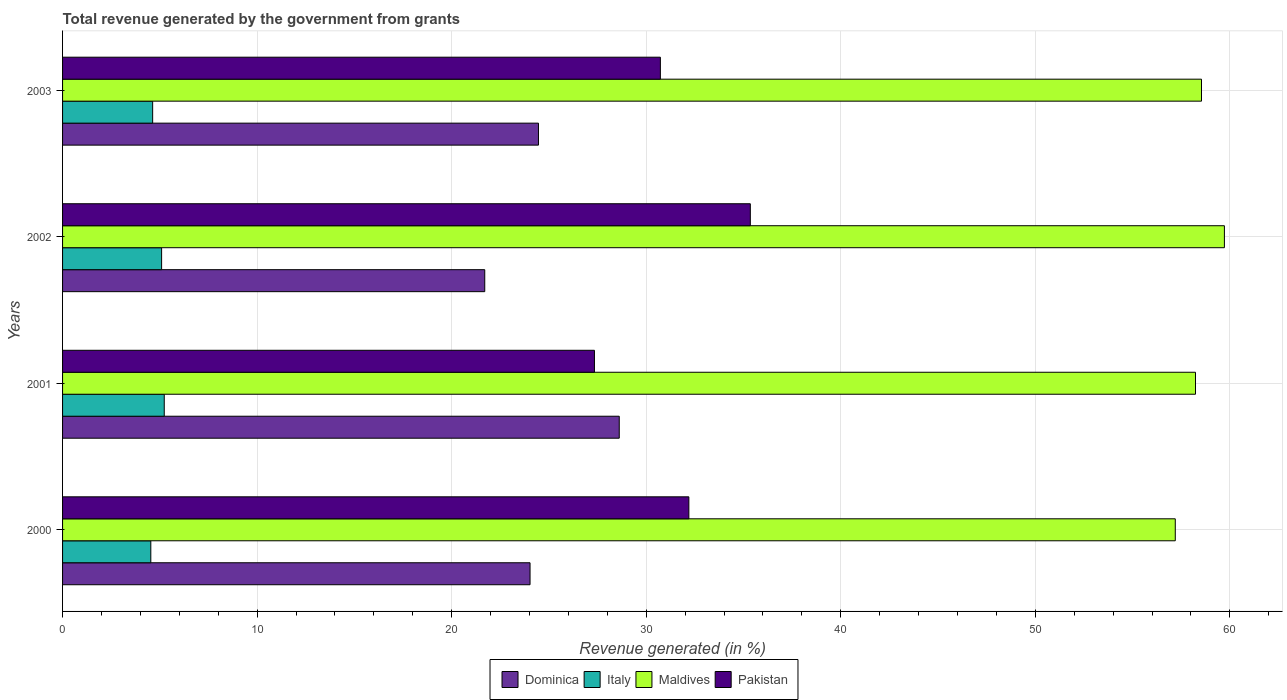How many different coloured bars are there?
Keep it short and to the point. 4. How many bars are there on the 4th tick from the top?
Your response must be concise. 4. In how many cases, is the number of bars for a given year not equal to the number of legend labels?
Provide a short and direct response. 0. What is the total revenue generated in Italy in 2001?
Offer a very short reply. 5.23. Across all years, what is the maximum total revenue generated in Maldives?
Provide a short and direct response. 59.72. Across all years, what is the minimum total revenue generated in Italy?
Give a very brief answer. 4.54. In which year was the total revenue generated in Italy maximum?
Offer a terse response. 2001. What is the total total revenue generated in Italy in the graph?
Provide a succinct answer. 19.48. What is the difference between the total revenue generated in Dominica in 2000 and that in 2001?
Offer a very short reply. -4.59. What is the difference between the total revenue generated in Italy in 2000 and the total revenue generated in Dominica in 2001?
Your response must be concise. -24.08. What is the average total revenue generated in Italy per year?
Provide a succinct answer. 4.87. In the year 2002, what is the difference between the total revenue generated in Italy and total revenue generated in Maldives?
Ensure brevity in your answer.  -54.63. What is the ratio of the total revenue generated in Pakistan in 2001 to that in 2003?
Provide a succinct answer. 0.89. Is the difference between the total revenue generated in Italy in 2000 and 2002 greater than the difference between the total revenue generated in Maldives in 2000 and 2002?
Provide a short and direct response. Yes. What is the difference between the highest and the second highest total revenue generated in Pakistan?
Give a very brief answer. 3.16. What is the difference between the highest and the lowest total revenue generated in Pakistan?
Ensure brevity in your answer.  8.01. In how many years, is the total revenue generated in Pakistan greater than the average total revenue generated in Pakistan taken over all years?
Make the answer very short. 2. What does the 3rd bar from the bottom in 2002 represents?
Provide a succinct answer. Maldives. How many years are there in the graph?
Ensure brevity in your answer.  4. What is the difference between two consecutive major ticks on the X-axis?
Your answer should be compact. 10. Are the values on the major ticks of X-axis written in scientific E-notation?
Your answer should be compact. No. Does the graph contain any zero values?
Your answer should be very brief. No. How many legend labels are there?
Give a very brief answer. 4. What is the title of the graph?
Provide a short and direct response. Total revenue generated by the government from grants. Does "Netherlands" appear as one of the legend labels in the graph?
Your answer should be very brief. No. What is the label or title of the X-axis?
Your answer should be compact. Revenue generated (in %). What is the Revenue generated (in %) of Dominica in 2000?
Your answer should be compact. 24.03. What is the Revenue generated (in %) of Italy in 2000?
Your response must be concise. 4.54. What is the Revenue generated (in %) in Maldives in 2000?
Provide a short and direct response. 57.2. What is the Revenue generated (in %) in Pakistan in 2000?
Your answer should be very brief. 32.19. What is the Revenue generated (in %) in Dominica in 2001?
Make the answer very short. 28.62. What is the Revenue generated (in %) in Italy in 2001?
Offer a very short reply. 5.23. What is the Revenue generated (in %) in Maldives in 2001?
Make the answer very short. 58.24. What is the Revenue generated (in %) of Pakistan in 2001?
Offer a very short reply. 27.34. What is the Revenue generated (in %) in Dominica in 2002?
Keep it short and to the point. 21.7. What is the Revenue generated (in %) in Italy in 2002?
Keep it short and to the point. 5.09. What is the Revenue generated (in %) of Maldives in 2002?
Provide a short and direct response. 59.72. What is the Revenue generated (in %) of Pakistan in 2002?
Your answer should be very brief. 35.35. What is the Revenue generated (in %) in Dominica in 2003?
Make the answer very short. 24.46. What is the Revenue generated (in %) in Italy in 2003?
Offer a very short reply. 4.63. What is the Revenue generated (in %) of Maldives in 2003?
Provide a succinct answer. 58.54. What is the Revenue generated (in %) in Pakistan in 2003?
Provide a succinct answer. 30.73. Across all years, what is the maximum Revenue generated (in %) in Dominica?
Keep it short and to the point. 28.62. Across all years, what is the maximum Revenue generated (in %) of Italy?
Your answer should be very brief. 5.23. Across all years, what is the maximum Revenue generated (in %) in Maldives?
Your answer should be very brief. 59.72. Across all years, what is the maximum Revenue generated (in %) in Pakistan?
Offer a very short reply. 35.35. Across all years, what is the minimum Revenue generated (in %) of Dominica?
Your answer should be very brief. 21.7. Across all years, what is the minimum Revenue generated (in %) in Italy?
Keep it short and to the point. 4.54. Across all years, what is the minimum Revenue generated (in %) in Maldives?
Provide a succinct answer. 57.2. Across all years, what is the minimum Revenue generated (in %) of Pakistan?
Offer a very short reply. 27.34. What is the total Revenue generated (in %) in Dominica in the graph?
Your answer should be very brief. 98.81. What is the total Revenue generated (in %) in Italy in the graph?
Your answer should be compact. 19.48. What is the total Revenue generated (in %) in Maldives in the graph?
Your answer should be compact. 233.7. What is the total Revenue generated (in %) of Pakistan in the graph?
Provide a short and direct response. 125.62. What is the difference between the Revenue generated (in %) in Dominica in 2000 and that in 2001?
Provide a short and direct response. -4.59. What is the difference between the Revenue generated (in %) in Italy in 2000 and that in 2001?
Your answer should be very brief. -0.69. What is the difference between the Revenue generated (in %) of Maldives in 2000 and that in 2001?
Your response must be concise. -1.04. What is the difference between the Revenue generated (in %) of Pakistan in 2000 and that in 2001?
Provide a short and direct response. 4.85. What is the difference between the Revenue generated (in %) of Dominica in 2000 and that in 2002?
Your answer should be very brief. 2.33. What is the difference between the Revenue generated (in %) of Italy in 2000 and that in 2002?
Ensure brevity in your answer.  -0.55. What is the difference between the Revenue generated (in %) of Maldives in 2000 and that in 2002?
Provide a succinct answer. -2.53. What is the difference between the Revenue generated (in %) of Pakistan in 2000 and that in 2002?
Provide a short and direct response. -3.16. What is the difference between the Revenue generated (in %) of Dominica in 2000 and that in 2003?
Provide a short and direct response. -0.43. What is the difference between the Revenue generated (in %) of Italy in 2000 and that in 2003?
Provide a succinct answer. -0.09. What is the difference between the Revenue generated (in %) in Maldives in 2000 and that in 2003?
Ensure brevity in your answer.  -1.35. What is the difference between the Revenue generated (in %) of Pakistan in 2000 and that in 2003?
Keep it short and to the point. 1.46. What is the difference between the Revenue generated (in %) of Dominica in 2001 and that in 2002?
Give a very brief answer. 6.91. What is the difference between the Revenue generated (in %) in Italy in 2001 and that in 2002?
Your answer should be very brief. 0.14. What is the difference between the Revenue generated (in %) in Maldives in 2001 and that in 2002?
Give a very brief answer. -1.49. What is the difference between the Revenue generated (in %) in Pakistan in 2001 and that in 2002?
Offer a very short reply. -8.01. What is the difference between the Revenue generated (in %) in Dominica in 2001 and that in 2003?
Offer a terse response. 4.15. What is the difference between the Revenue generated (in %) of Italy in 2001 and that in 2003?
Your response must be concise. 0.6. What is the difference between the Revenue generated (in %) of Maldives in 2001 and that in 2003?
Give a very brief answer. -0.31. What is the difference between the Revenue generated (in %) in Pakistan in 2001 and that in 2003?
Make the answer very short. -3.39. What is the difference between the Revenue generated (in %) in Dominica in 2002 and that in 2003?
Offer a very short reply. -2.76. What is the difference between the Revenue generated (in %) in Italy in 2002 and that in 2003?
Give a very brief answer. 0.46. What is the difference between the Revenue generated (in %) of Maldives in 2002 and that in 2003?
Your answer should be very brief. 1.18. What is the difference between the Revenue generated (in %) in Pakistan in 2002 and that in 2003?
Make the answer very short. 4.62. What is the difference between the Revenue generated (in %) in Dominica in 2000 and the Revenue generated (in %) in Italy in 2001?
Your answer should be very brief. 18.8. What is the difference between the Revenue generated (in %) in Dominica in 2000 and the Revenue generated (in %) in Maldives in 2001?
Your answer should be compact. -34.21. What is the difference between the Revenue generated (in %) of Dominica in 2000 and the Revenue generated (in %) of Pakistan in 2001?
Ensure brevity in your answer.  -3.31. What is the difference between the Revenue generated (in %) of Italy in 2000 and the Revenue generated (in %) of Maldives in 2001?
Your answer should be very brief. -53.7. What is the difference between the Revenue generated (in %) in Italy in 2000 and the Revenue generated (in %) in Pakistan in 2001?
Make the answer very short. -22.8. What is the difference between the Revenue generated (in %) in Maldives in 2000 and the Revenue generated (in %) in Pakistan in 2001?
Your response must be concise. 29.86. What is the difference between the Revenue generated (in %) in Dominica in 2000 and the Revenue generated (in %) in Italy in 2002?
Your response must be concise. 18.94. What is the difference between the Revenue generated (in %) in Dominica in 2000 and the Revenue generated (in %) in Maldives in 2002?
Your response must be concise. -35.69. What is the difference between the Revenue generated (in %) of Dominica in 2000 and the Revenue generated (in %) of Pakistan in 2002?
Keep it short and to the point. -11.32. What is the difference between the Revenue generated (in %) in Italy in 2000 and the Revenue generated (in %) in Maldives in 2002?
Offer a terse response. -55.19. What is the difference between the Revenue generated (in %) in Italy in 2000 and the Revenue generated (in %) in Pakistan in 2002?
Your response must be concise. -30.82. What is the difference between the Revenue generated (in %) in Maldives in 2000 and the Revenue generated (in %) in Pakistan in 2002?
Offer a terse response. 21.84. What is the difference between the Revenue generated (in %) of Dominica in 2000 and the Revenue generated (in %) of Italy in 2003?
Your answer should be compact. 19.4. What is the difference between the Revenue generated (in %) of Dominica in 2000 and the Revenue generated (in %) of Maldives in 2003?
Offer a terse response. -34.51. What is the difference between the Revenue generated (in %) of Dominica in 2000 and the Revenue generated (in %) of Pakistan in 2003?
Your answer should be very brief. -6.7. What is the difference between the Revenue generated (in %) of Italy in 2000 and the Revenue generated (in %) of Maldives in 2003?
Keep it short and to the point. -54.01. What is the difference between the Revenue generated (in %) of Italy in 2000 and the Revenue generated (in %) of Pakistan in 2003?
Offer a very short reply. -26.19. What is the difference between the Revenue generated (in %) in Maldives in 2000 and the Revenue generated (in %) in Pakistan in 2003?
Provide a succinct answer. 26.47. What is the difference between the Revenue generated (in %) in Dominica in 2001 and the Revenue generated (in %) in Italy in 2002?
Your response must be concise. 23.52. What is the difference between the Revenue generated (in %) of Dominica in 2001 and the Revenue generated (in %) of Maldives in 2002?
Keep it short and to the point. -31.11. What is the difference between the Revenue generated (in %) in Dominica in 2001 and the Revenue generated (in %) in Pakistan in 2002?
Provide a short and direct response. -6.74. What is the difference between the Revenue generated (in %) in Italy in 2001 and the Revenue generated (in %) in Maldives in 2002?
Your answer should be very brief. -54.5. What is the difference between the Revenue generated (in %) of Italy in 2001 and the Revenue generated (in %) of Pakistan in 2002?
Offer a very short reply. -30.13. What is the difference between the Revenue generated (in %) of Maldives in 2001 and the Revenue generated (in %) of Pakistan in 2002?
Your response must be concise. 22.88. What is the difference between the Revenue generated (in %) of Dominica in 2001 and the Revenue generated (in %) of Italy in 2003?
Your response must be concise. 23.98. What is the difference between the Revenue generated (in %) in Dominica in 2001 and the Revenue generated (in %) in Maldives in 2003?
Provide a succinct answer. -29.93. What is the difference between the Revenue generated (in %) in Dominica in 2001 and the Revenue generated (in %) in Pakistan in 2003?
Ensure brevity in your answer.  -2.11. What is the difference between the Revenue generated (in %) of Italy in 2001 and the Revenue generated (in %) of Maldives in 2003?
Offer a very short reply. -53.32. What is the difference between the Revenue generated (in %) in Italy in 2001 and the Revenue generated (in %) in Pakistan in 2003?
Offer a very short reply. -25.5. What is the difference between the Revenue generated (in %) of Maldives in 2001 and the Revenue generated (in %) of Pakistan in 2003?
Provide a short and direct response. 27.51. What is the difference between the Revenue generated (in %) in Dominica in 2002 and the Revenue generated (in %) in Italy in 2003?
Make the answer very short. 17.07. What is the difference between the Revenue generated (in %) in Dominica in 2002 and the Revenue generated (in %) in Maldives in 2003?
Provide a succinct answer. -36.84. What is the difference between the Revenue generated (in %) in Dominica in 2002 and the Revenue generated (in %) in Pakistan in 2003?
Offer a very short reply. -9.03. What is the difference between the Revenue generated (in %) in Italy in 2002 and the Revenue generated (in %) in Maldives in 2003?
Provide a succinct answer. -53.45. What is the difference between the Revenue generated (in %) of Italy in 2002 and the Revenue generated (in %) of Pakistan in 2003?
Provide a succinct answer. -25.64. What is the difference between the Revenue generated (in %) in Maldives in 2002 and the Revenue generated (in %) in Pakistan in 2003?
Offer a terse response. 28.99. What is the average Revenue generated (in %) of Dominica per year?
Provide a short and direct response. 24.7. What is the average Revenue generated (in %) of Italy per year?
Your answer should be very brief. 4.87. What is the average Revenue generated (in %) in Maldives per year?
Keep it short and to the point. 58.42. What is the average Revenue generated (in %) of Pakistan per year?
Provide a short and direct response. 31.4. In the year 2000, what is the difference between the Revenue generated (in %) in Dominica and Revenue generated (in %) in Italy?
Make the answer very short. 19.49. In the year 2000, what is the difference between the Revenue generated (in %) of Dominica and Revenue generated (in %) of Maldives?
Ensure brevity in your answer.  -33.17. In the year 2000, what is the difference between the Revenue generated (in %) in Dominica and Revenue generated (in %) in Pakistan?
Your answer should be compact. -8.16. In the year 2000, what is the difference between the Revenue generated (in %) of Italy and Revenue generated (in %) of Maldives?
Your response must be concise. -52.66. In the year 2000, what is the difference between the Revenue generated (in %) in Italy and Revenue generated (in %) in Pakistan?
Your response must be concise. -27.66. In the year 2000, what is the difference between the Revenue generated (in %) in Maldives and Revenue generated (in %) in Pakistan?
Provide a short and direct response. 25. In the year 2001, what is the difference between the Revenue generated (in %) of Dominica and Revenue generated (in %) of Italy?
Offer a very short reply. 23.39. In the year 2001, what is the difference between the Revenue generated (in %) in Dominica and Revenue generated (in %) in Maldives?
Offer a terse response. -29.62. In the year 2001, what is the difference between the Revenue generated (in %) in Dominica and Revenue generated (in %) in Pakistan?
Make the answer very short. 1.27. In the year 2001, what is the difference between the Revenue generated (in %) in Italy and Revenue generated (in %) in Maldives?
Provide a succinct answer. -53.01. In the year 2001, what is the difference between the Revenue generated (in %) in Italy and Revenue generated (in %) in Pakistan?
Your answer should be compact. -22.11. In the year 2001, what is the difference between the Revenue generated (in %) of Maldives and Revenue generated (in %) of Pakistan?
Your answer should be compact. 30.9. In the year 2002, what is the difference between the Revenue generated (in %) in Dominica and Revenue generated (in %) in Italy?
Provide a short and direct response. 16.61. In the year 2002, what is the difference between the Revenue generated (in %) of Dominica and Revenue generated (in %) of Maldives?
Your answer should be compact. -38.02. In the year 2002, what is the difference between the Revenue generated (in %) in Dominica and Revenue generated (in %) in Pakistan?
Give a very brief answer. -13.65. In the year 2002, what is the difference between the Revenue generated (in %) in Italy and Revenue generated (in %) in Maldives?
Ensure brevity in your answer.  -54.63. In the year 2002, what is the difference between the Revenue generated (in %) of Italy and Revenue generated (in %) of Pakistan?
Your answer should be very brief. -30.26. In the year 2002, what is the difference between the Revenue generated (in %) in Maldives and Revenue generated (in %) in Pakistan?
Your answer should be very brief. 24.37. In the year 2003, what is the difference between the Revenue generated (in %) of Dominica and Revenue generated (in %) of Italy?
Your response must be concise. 19.83. In the year 2003, what is the difference between the Revenue generated (in %) in Dominica and Revenue generated (in %) in Maldives?
Ensure brevity in your answer.  -34.08. In the year 2003, what is the difference between the Revenue generated (in %) in Dominica and Revenue generated (in %) in Pakistan?
Your answer should be compact. -6.27. In the year 2003, what is the difference between the Revenue generated (in %) in Italy and Revenue generated (in %) in Maldives?
Your answer should be very brief. -53.91. In the year 2003, what is the difference between the Revenue generated (in %) of Italy and Revenue generated (in %) of Pakistan?
Your answer should be very brief. -26.1. In the year 2003, what is the difference between the Revenue generated (in %) in Maldives and Revenue generated (in %) in Pakistan?
Make the answer very short. 27.82. What is the ratio of the Revenue generated (in %) of Dominica in 2000 to that in 2001?
Ensure brevity in your answer.  0.84. What is the ratio of the Revenue generated (in %) of Italy in 2000 to that in 2001?
Your answer should be very brief. 0.87. What is the ratio of the Revenue generated (in %) in Maldives in 2000 to that in 2001?
Offer a terse response. 0.98. What is the ratio of the Revenue generated (in %) in Pakistan in 2000 to that in 2001?
Provide a succinct answer. 1.18. What is the ratio of the Revenue generated (in %) of Dominica in 2000 to that in 2002?
Offer a very short reply. 1.11. What is the ratio of the Revenue generated (in %) of Italy in 2000 to that in 2002?
Keep it short and to the point. 0.89. What is the ratio of the Revenue generated (in %) of Maldives in 2000 to that in 2002?
Ensure brevity in your answer.  0.96. What is the ratio of the Revenue generated (in %) in Pakistan in 2000 to that in 2002?
Provide a succinct answer. 0.91. What is the ratio of the Revenue generated (in %) in Dominica in 2000 to that in 2003?
Offer a terse response. 0.98. What is the ratio of the Revenue generated (in %) of Italy in 2000 to that in 2003?
Provide a succinct answer. 0.98. What is the ratio of the Revenue generated (in %) in Pakistan in 2000 to that in 2003?
Your answer should be compact. 1.05. What is the ratio of the Revenue generated (in %) of Dominica in 2001 to that in 2002?
Your answer should be compact. 1.32. What is the ratio of the Revenue generated (in %) of Italy in 2001 to that in 2002?
Ensure brevity in your answer.  1.03. What is the ratio of the Revenue generated (in %) of Maldives in 2001 to that in 2002?
Offer a very short reply. 0.98. What is the ratio of the Revenue generated (in %) of Pakistan in 2001 to that in 2002?
Ensure brevity in your answer.  0.77. What is the ratio of the Revenue generated (in %) in Dominica in 2001 to that in 2003?
Offer a terse response. 1.17. What is the ratio of the Revenue generated (in %) of Italy in 2001 to that in 2003?
Your answer should be compact. 1.13. What is the ratio of the Revenue generated (in %) in Pakistan in 2001 to that in 2003?
Offer a terse response. 0.89. What is the ratio of the Revenue generated (in %) of Dominica in 2002 to that in 2003?
Provide a short and direct response. 0.89. What is the ratio of the Revenue generated (in %) of Italy in 2002 to that in 2003?
Offer a very short reply. 1.1. What is the ratio of the Revenue generated (in %) of Maldives in 2002 to that in 2003?
Offer a very short reply. 1.02. What is the ratio of the Revenue generated (in %) of Pakistan in 2002 to that in 2003?
Your answer should be very brief. 1.15. What is the difference between the highest and the second highest Revenue generated (in %) in Dominica?
Ensure brevity in your answer.  4.15. What is the difference between the highest and the second highest Revenue generated (in %) of Italy?
Make the answer very short. 0.14. What is the difference between the highest and the second highest Revenue generated (in %) in Maldives?
Ensure brevity in your answer.  1.18. What is the difference between the highest and the second highest Revenue generated (in %) in Pakistan?
Make the answer very short. 3.16. What is the difference between the highest and the lowest Revenue generated (in %) of Dominica?
Ensure brevity in your answer.  6.91. What is the difference between the highest and the lowest Revenue generated (in %) of Italy?
Give a very brief answer. 0.69. What is the difference between the highest and the lowest Revenue generated (in %) in Maldives?
Keep it short and to the point. 2.53. What is the difference between the highest and the lowest Revenue generated (in %) of Pakistan?
Your answer should be compact. 8.01. 